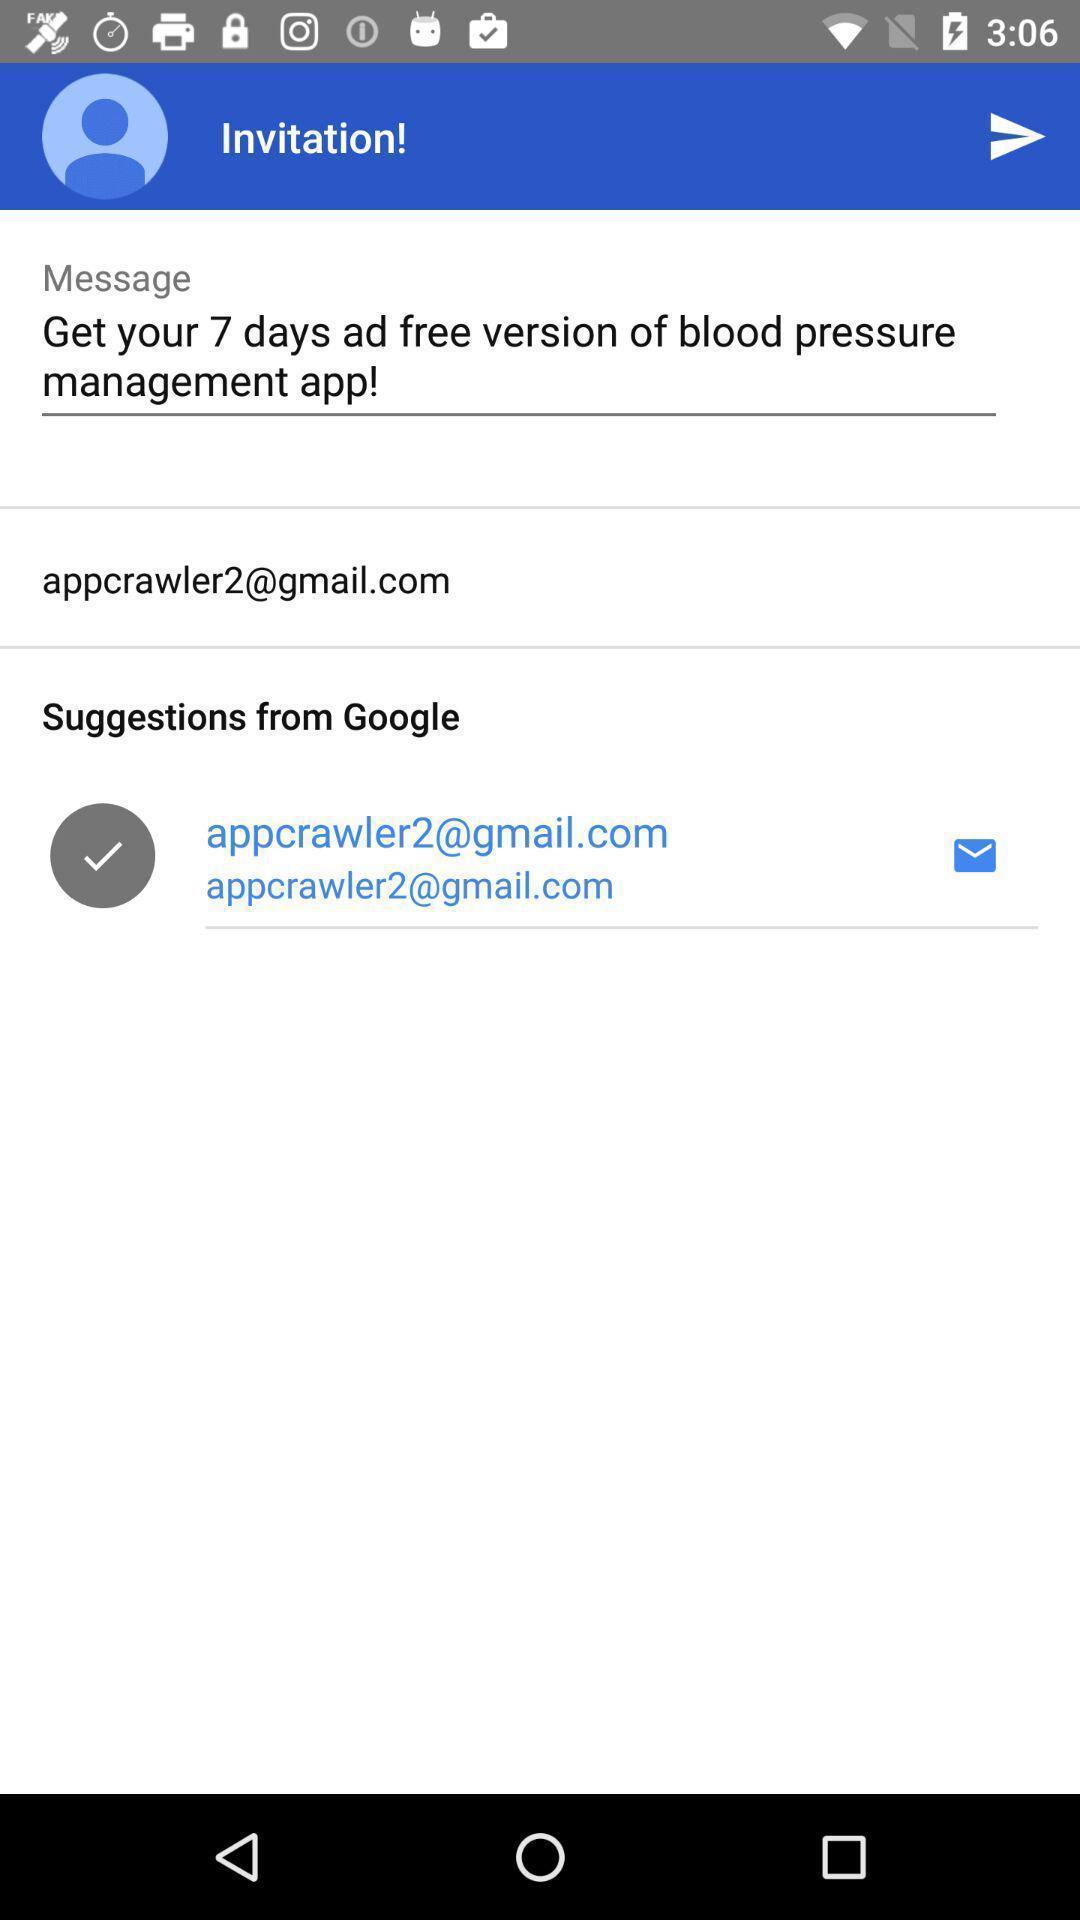What is the overall content of this screenshot? Screen displaying user email information and contents of a message. 